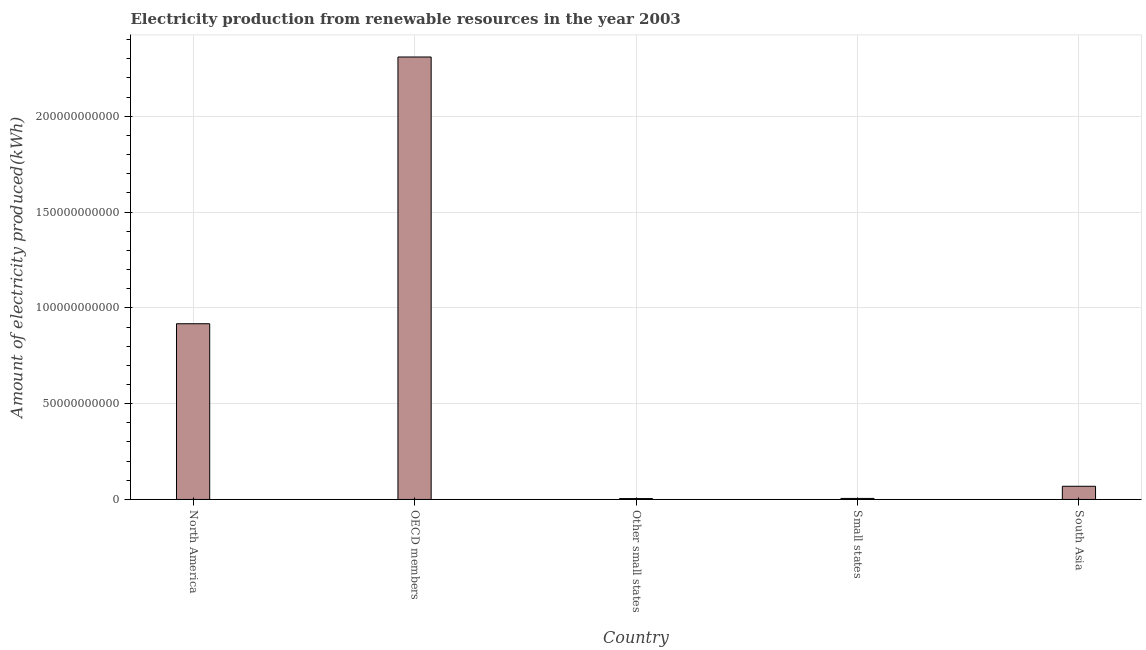Does the graph contain any zero values?
Offer a very short reply. No. Does the graph contain grids?
Your answer should be compact. Yes. What is the title of the graph?
Make the answer very short. Electricity production from renewable resources in the year 2003. What is the label or title of the Y-axis?
Give a very brief answer. Amount of electricity produced(kWh). What is the amount of electricity produced in OECD members?
Provide a succinct answer. 2.31e+11. Across all countries, what is the maximum amount of electricity produced?
Give a very brief answer. 2.31e+11. Across all countries, what is the minimum amount of electricity produced?
Provide a short and direct response. 4.57e+08. In which country was the amount of electricity produced maximum?
Provide a succinct answer. OECD members. In which country was the amount of electricity produced minimum?
Your answer should be compact. Other small states. What is the sum of the amount of electricity produced?
Ensure brevity in your answer.  3.31e+11. What is the difference between the amount of electricity produced in OECD members and South Asia?
Provide a short and direct response. 2.24e+11. What is the average amount of electricity produced per country?
Your answer should be compact. 6.61e+1. What is the median amount of electricity produced?
Your answer should be compact. 6.88e+09. In how many countries, is the amount of electricity produced greater than 210000000000 kWh?
Keep it short and to the point. 1. What is the ratio of the amount of electricity produced in North America to that in South Asia?
Your answer should be very brief. 13.34. Is the difference between the amount of electricity produced in North America and Other small states greater than the difference between any two countries?
Offer a terse response. No. What is the difference between the highest and the second highest amount of electricity produced?
Ensure brevity in your answer.  1.39e+11. Is the sum of the amount of electricity produced in North America and OECD members greater than the maximum amount of electricity produced across all countries?
Provide a short and direct response. Yes. What is the difference between the highest and the lowest amount of electricity produced?
Provide a succinct answer. 2.30e+11. How many countries are there in the graph?
Your answer should be very brief. 5. What is the difference between two consecutive major ticks on the Y-axis?
Provide a succinct answer. 5.00e+1. Are the values on the major ticks of Y-axis written in scientific E-notation?
Offer a terse response. No. What is the Amount of electricity produced(kWh) of North America?
Keep it short and to the point. 9.17e+1. What is the Amount of electricity produced(kWh) in OECD members?
Provide a succinct answer. 2.31e+11. What is the Amount of electricity produced(kWh) of Other small states?
Give a very brief answer. 4.57e+08. What is the Amount of electricity produced(kWh) of Small states?
Provide a succinct answer. 5.32e+08. What is the Amount of electricity produced(kWh) of South Asia?
Offer a terse response. 6.88e+09. What is the difference between the Amount of electricity produced(kWh) in North America and OECD members?
Your answer should be compact. -1.39e+11. What is the difference between the Amount of electricity produced(kWh) in North America and Other small states?
Give a very brief answer. 9.13e+1. What is the difference between the Amount of electricity produced(kWh) in North America and Small states?
Your answer should be very brief. 9.12e+1. What is the difference between the Amount of electricity produced(kWh) in North America and South Asia?
Keep it short and to the point. 8.48e+1. What is the difference between the Amount of electricity produced(kWh) in OECD members and Other small states?
Provide a short and direct response. 2.30e+11. What is the difference between the Amount of electricity produced(kWh) in OECD members and Small states?
Your response must be concise. 2.30e+11. What is the difference between the Amount of electricity produced(kWh) in OECD members and South Asia?
Make the answer very short. 2.24e+11. What is the difference between the Amount of electricity produced(kWh) in Other small states and Small states?
Offer a very short reply. -7.50e+07. What is the difference between the Amount of electricity produced(kWh) in Other small states and South Asia?
Your answer should be very brief. -6.42e+09. What is the difference between the Amount of electricity produced(kWh) in Small states and South Asia?
Provide a short and direct response. -6.34e+09. What is the ratio of the Amount of electricity produced(kWh) in North America to that in OECD members?
Your response must be concise. 0.4. What is the ratio of the Amount of electricity produced(kWh) in North America to that in Other small states?
Your answer should be compact. 200.68. What is the ratio of the Amount of electricity produced(kWh) in North America to that in Small states?
Provide a short and direct response. 172.39. What is the ratio of the Amount of electricity produced(kWh) in North America to that in South Asia?
Offer a terse response. 13.34. What is the ratio of the Amount of electricity produced(kWh) in OECD members to that in Other small states?
Ensure brevity in your answer.  505.33. What is the ratio of the Amount of electricity produced(kWh) in OECD members to that in Small states?
Your answer should be compact. 434.09. What is the ratio of the Amount of electricity produced(kWh) in OECD members to that in South Asia?
Offer a terse response. 33.59. What is the ratio of the Amount of electricity produced(kWh) in Other small states to that in Small states?
Offer a very short reply. 0.86. What is the ratio of the Amount of electricity produced(kWh) in Other small states to that in South Asia?
Give a very brief answer. 0.07. What is the ratio of the Amount of electricity produced(kWh) in Small states to that in South Asia?
Give a very brief answer. 0.08. 